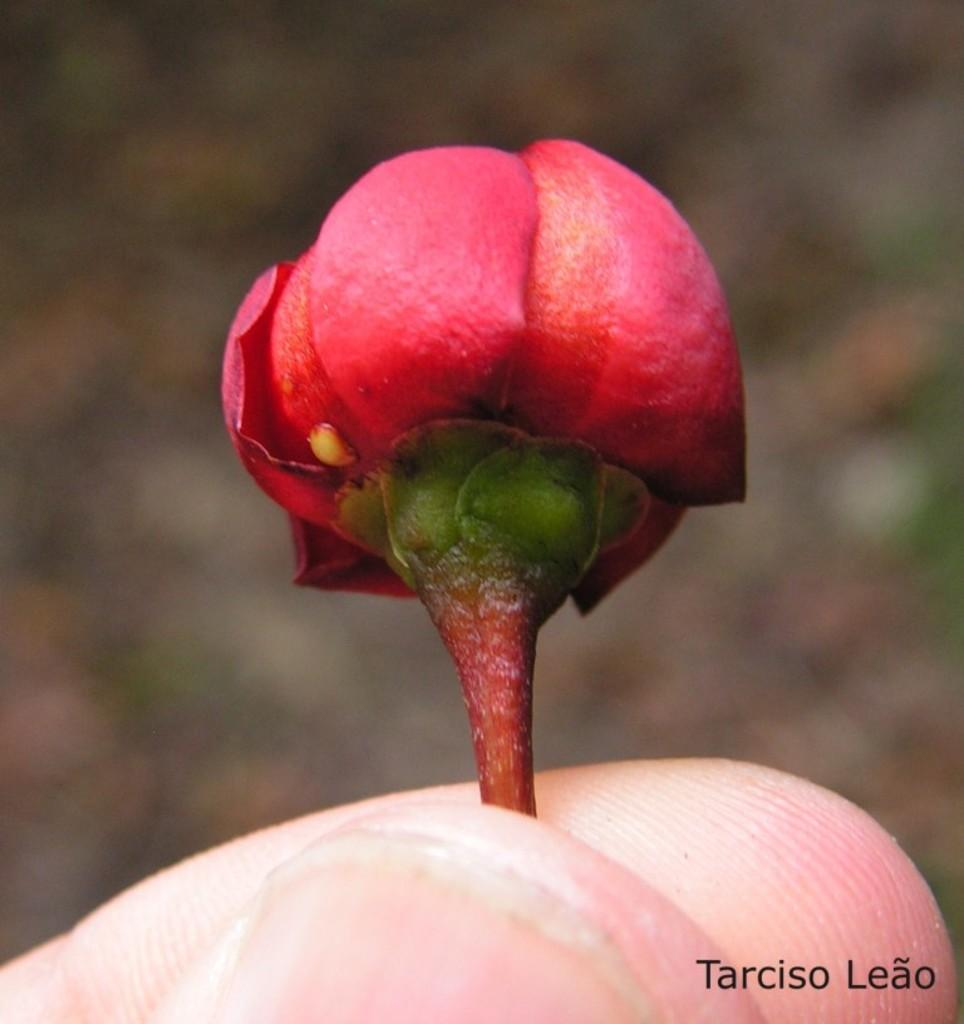What part of a person's body is visible in the image? There is a person's finger in the image. What type of flower can be seen in the image? There is a red color flower in the image. How would you describe the background of the image? The background of the image is blurry. Where is the text located in the image? The text is at the right bottom of the image. What type of clover is growing near the coast in the image? There is no coast or clover present in the image. The image does not depict a coast or clover; it features a person's finger and a red color flower with a blurry background and some text at the right bottom. 